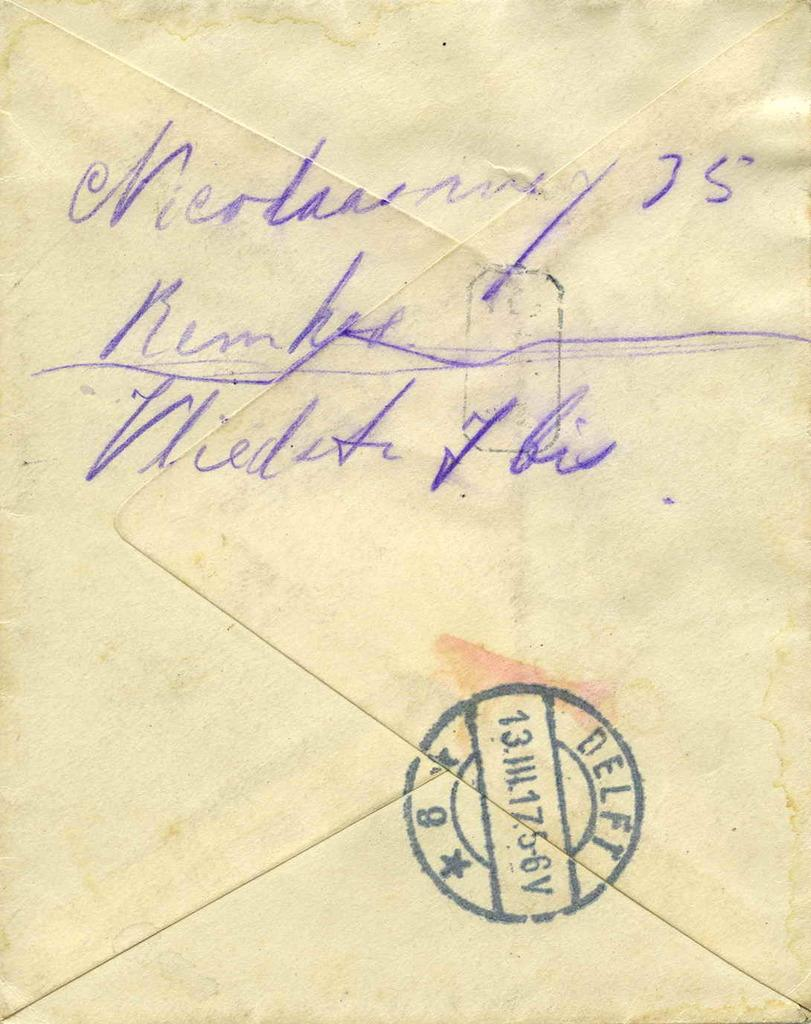<image>
Offer a succinct explanation of the picture presented. a close up of an envelope address with stamp reading DELFT 